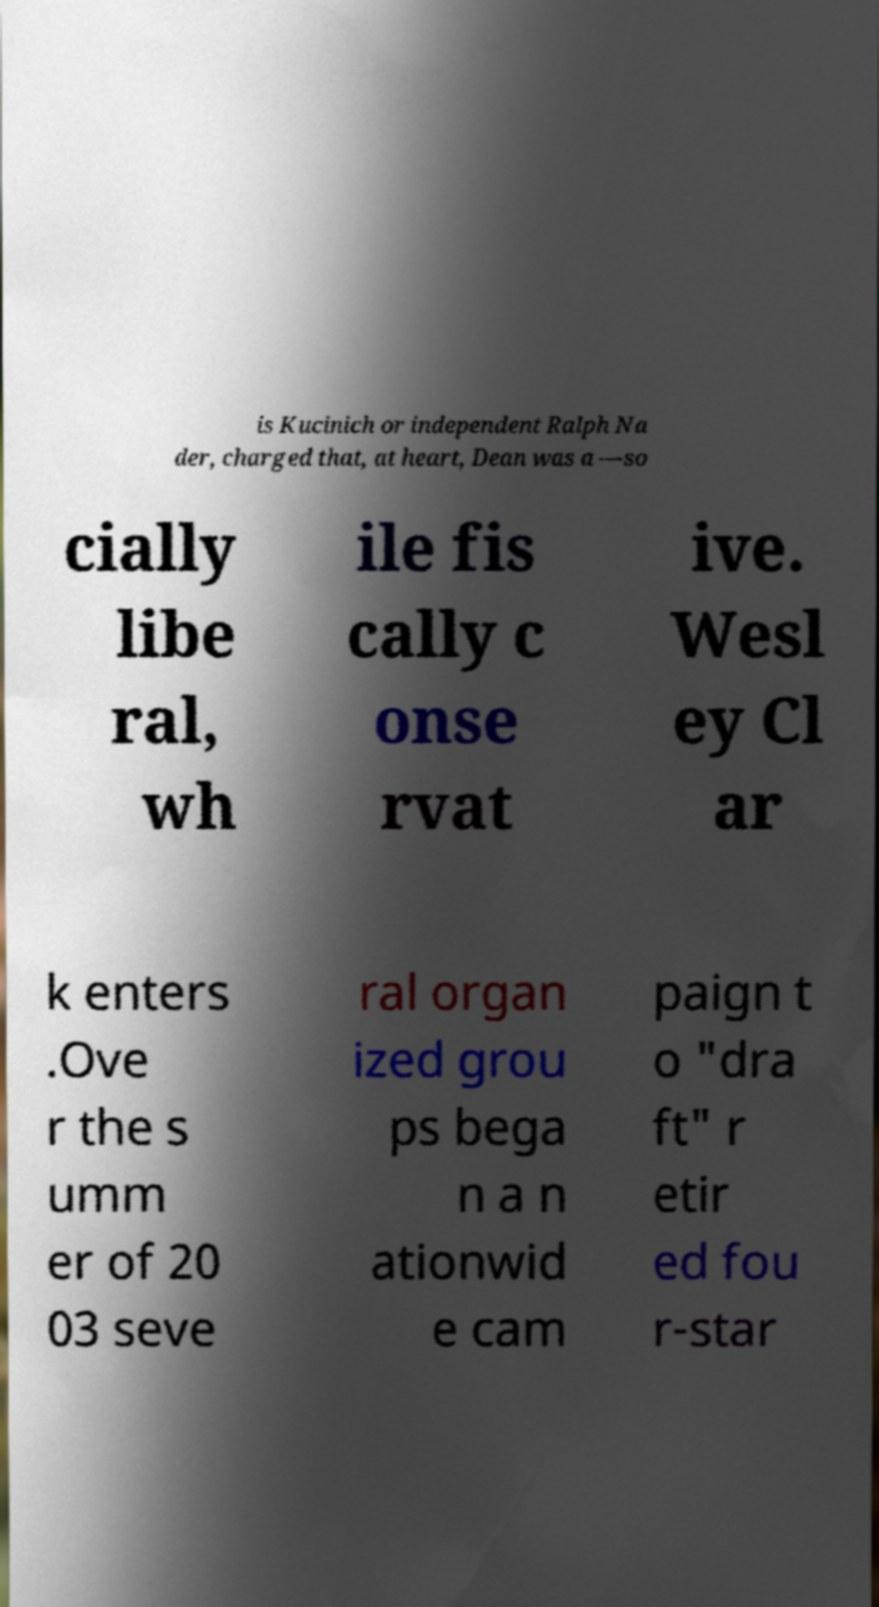I need the written content from this picture converted into text. Can you do that? is Kucinich or independent Ralph Na der, charged that, at heart, Dean was a —so cially libe ral, wh ile fis cally c onse rvat ive. Wesl ey Cl ar k enters .Ove r the s umm er of 20 03 seve ral organ ized grou ps bega n a n ationwid e cam paign t o "dra ft" r etir ed fou r-star 